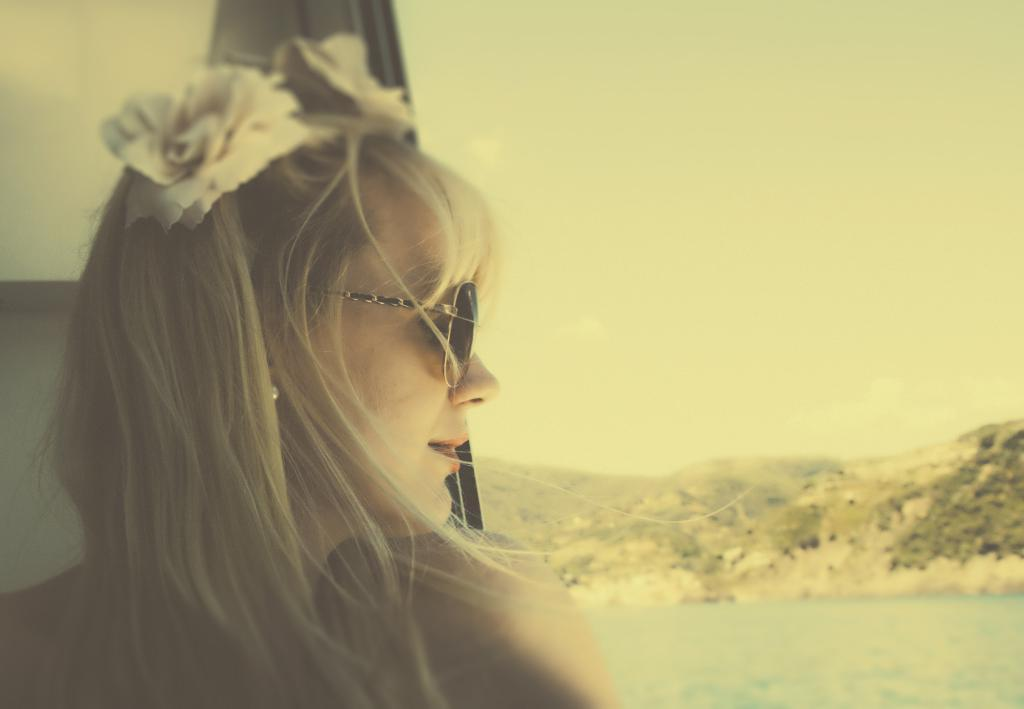What is located on the left side of the image? There is a woman on the left side of the image. What is the woman wearing in the image? The woman is wearing spectacles in the image. What can be seen in the background of the image? There is water and trees visible in the background of the image. How many kitties are playing with chalk on the right side of the image? There are no kitties or chalk present on the right side of the image. 